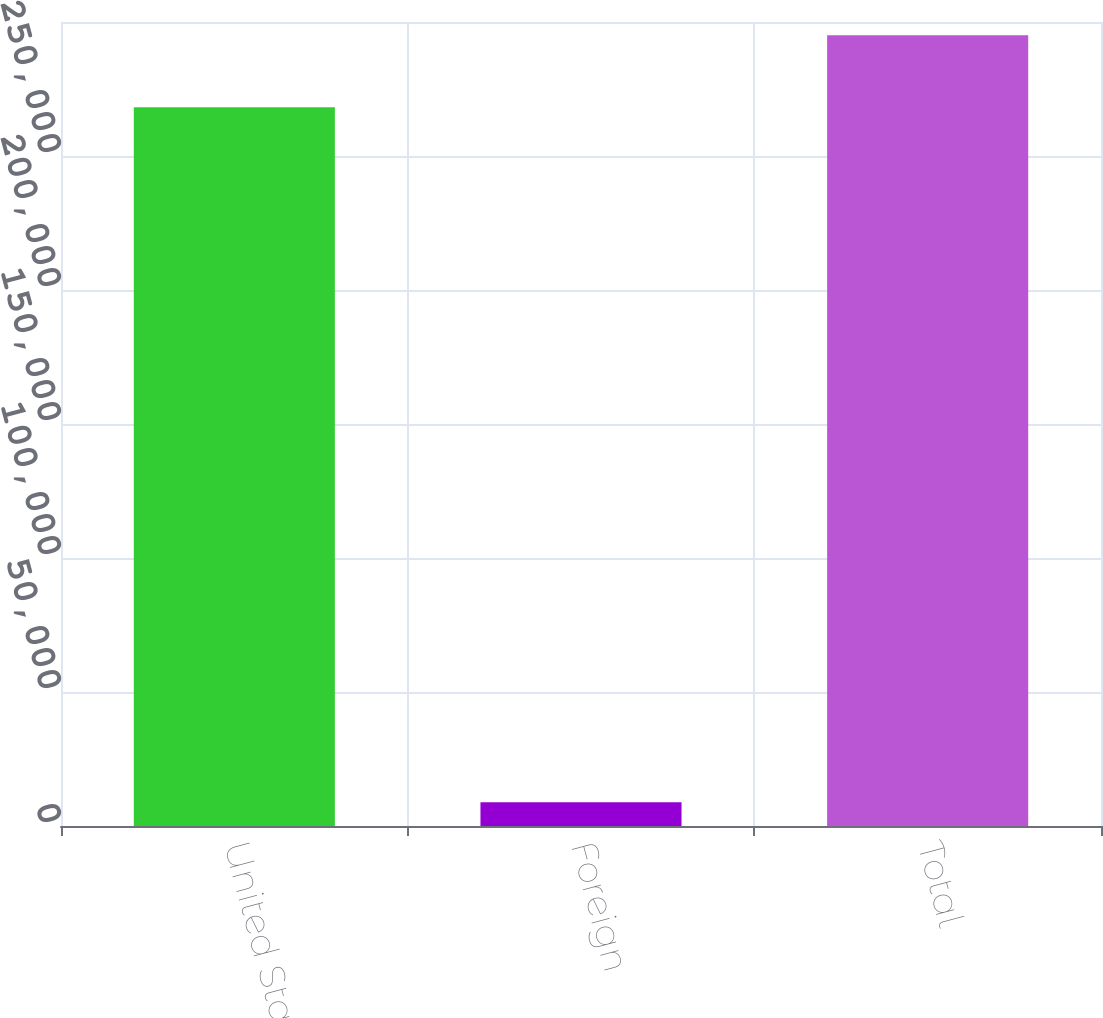Convert chart to OTSL. <chart><loc_0><loc_0><loc_500><loc_500><bar_chart><fcel>United States<fcel>Foreign<fcel>Total<nl><fcel>268229<fcel>8859<fcel>295052<nl></chart> 